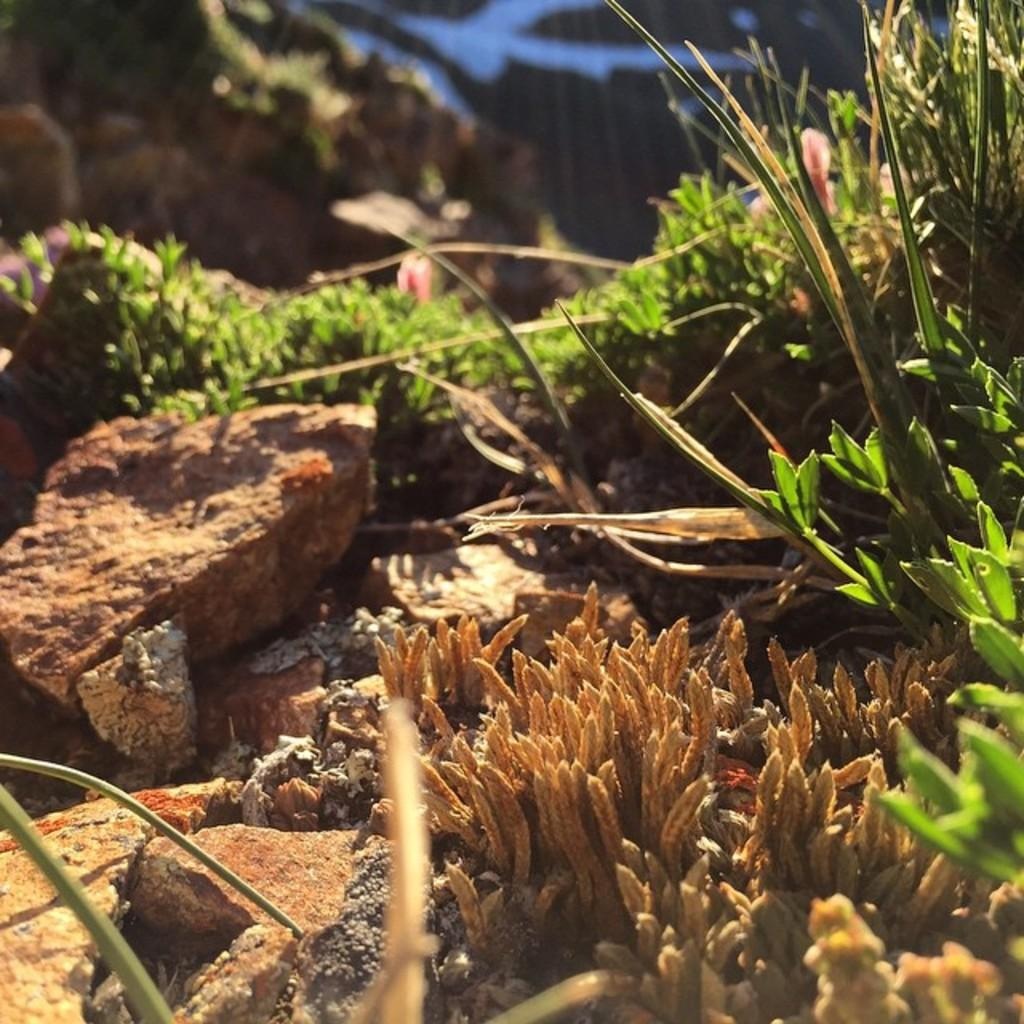What type of vegetation can be seen in the image? There are plants and grass in the image. Are there any water plants visible in the image? Yes, there are water plants in the image. What other natural elements can be seen in the image? There are rocks in the image. What type of metal is used to create the quill in the image? There is no quill present in the image, so it is not possible to determine the type of metal used. 